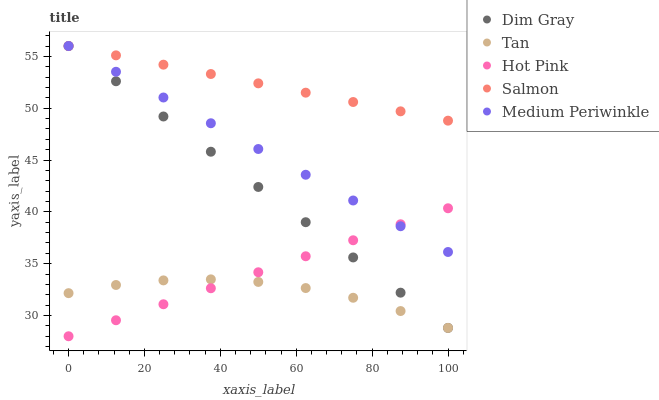Does Tan have the minimum area under the curve?
Answer yes or no. Yes. Does Salmon have the maximum area under the curve?
Answer yes or no. Yes. Does Dim Gray have the minimum area under the curve?
Answer yes or no. No. Does Dim Gray have the maximum area under the curve?
Answer yes or no. No. Is Medium Periwinkle the smoothest?
Answer yes or no. Yes. Is Tan the roughest?
Answer yes or no. Yes. Is Dim Gray the smoothest?
Answer yes or no. No. Is Dim Gray the roughest?
Answer yes or no. No. Does Hot Pink have the lowest value?
Answer yes or no. Yes. Does Tan have the lowest value?
Answer yes or no. No. Does Salmon have the highest value?
Answer yes or no. Yes. Does Tan have the highest value?
Answer yes or no. No. Is Tan less than Salmon?
Answer yes or no. Yes. Is Salmon greater than Tan?
Answer yes or no. Yes. Does Dim Gray intersect Medium Periwinkle?
Answer yes or no. Yes. Is Dim Gray less than Medium Periwinkle?
Answer yes or no. No. Is Dim Gray greater than Medium Periwinkle?
Answer yes or no. No. Does Tan intersect Salmon?
Answer yes or no. No. 